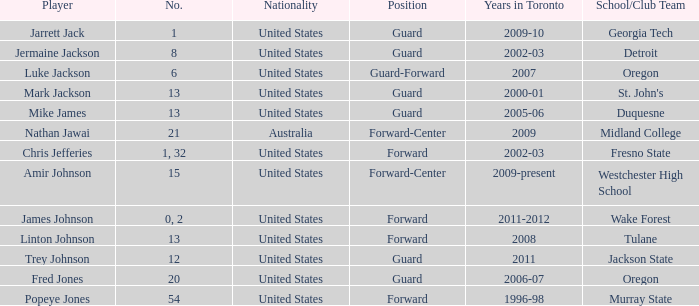What school/club team is Amir Johnson on? Westchester High School. 